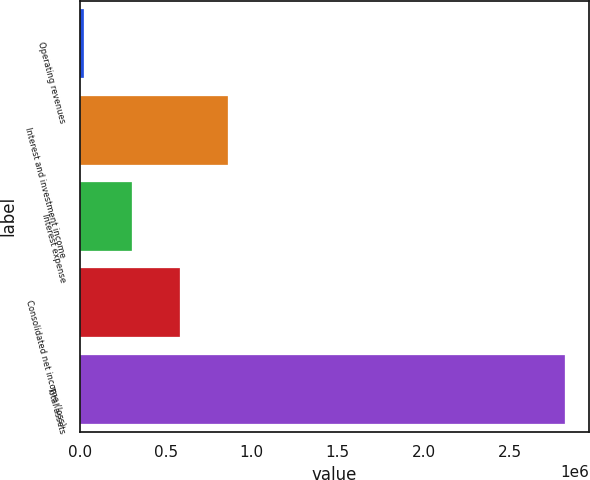Convert chart to OTSL. <chart><loc_0><loc_0><loc_500><loc_500><bar_chart><fcel>Operating revenues<fcel>Interest and investment income<fcel>Interest expense<fcel>Consolidated net income (loss)<fcel>Total assets<nl><fcel>26463<fcel>863975<fcel>305634<fcel>584804<fcel>2.81817e+06<nl></chart> 